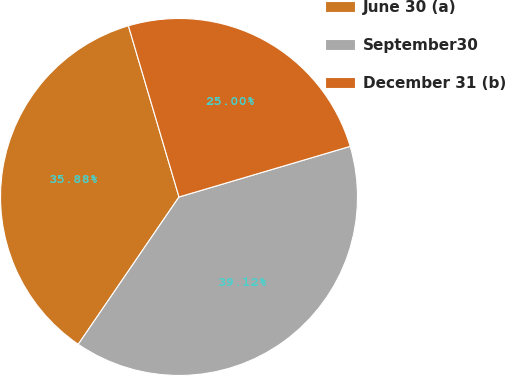Convert chart. <chart><loc_0><loc_0><loc_500><loc_500><pie_chart><fcel>June 30 (a)<fcel>September30<fcel>December 31 (b)<nl><fcel>35.88%<fcel>39.12%<fcel>25.0%<nl></chart> 